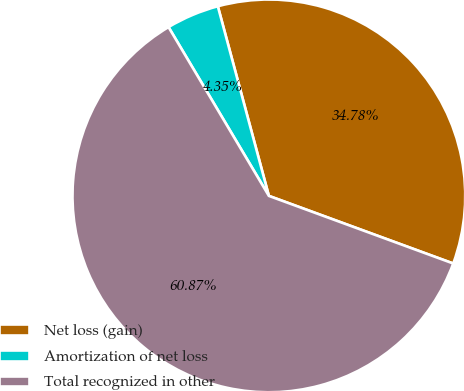Convert chart to OTSL. <chart><loc_0><loc_0><loc_500><loc_500><pie_chart><fcel>Net loss (gain)<fcel>Amortization of net loss<fcel>Total recognized in other<nl><fcel>34.78%<fcel>4.35%<fcel>60.87%<nl></chart> 